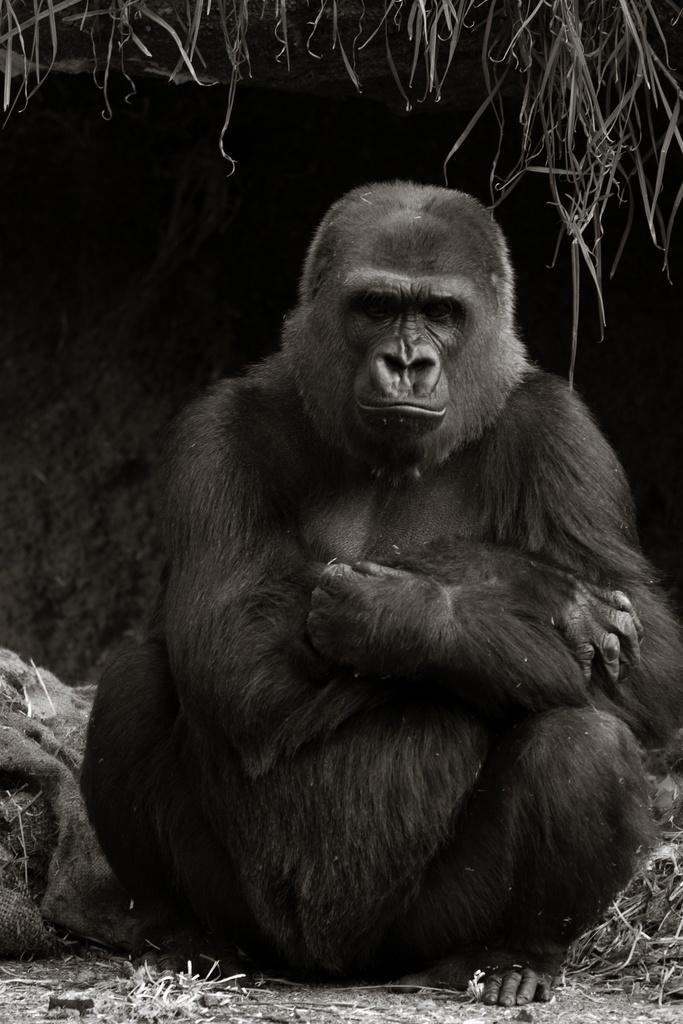Can you describe this image briefly? In this image, we can see a gorilla is sitting on the ground. 